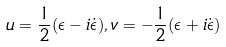<formula> <loc_0><loc_0><loc_500><loc_500>u = \frac { 1 } { 2 } ( \epsilon - i \dot { \epsilon } ) , v = - \frac { 1 } { 2 } ( \epsilon + i \dot { \epsilon } )</formula> 